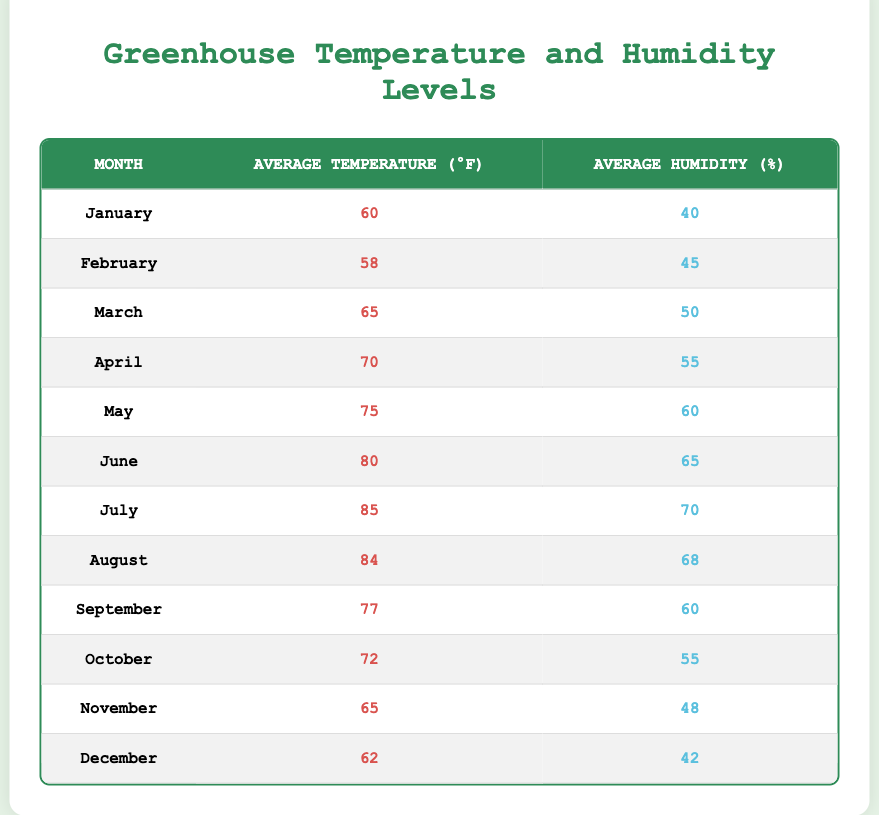What is the average temperature in July? The table indicates that the average temperature in July is 85°F.
Answer: 85°F What is the average humidity in January? According to the table, January has an average humidity of 40%.
Answer: 40% Which month has the highest average temperature? The highest average temperature is in July, which is 85°F.
Answer: July What is the average humidity for the months of June and July? To find the average, sum the average humidity values for June (65%) and July (70%), which totals 135%. Then, divide by 2 to find the average: 135% / 2 = 67.5%.
Answer: 67.5% Is the average humidity higher in December than in February? The average humidity in December is 42%, while in February it is 45%, which means February has a higher average humidity.
Answer: No What is the difference between the highest and lowest average temperatures in the table? The highest average temperature is in July (85°F) and the lowest is in February (58°F). The difference is 85°F - 58°F = 27°F.
Answer: 27°F Which month shows a decrease in average temperature from July to August? The average temperature in July is 85°F, and in August it goes down to 84°F, indicating a decrease.
Answer: Yes What is the average temperature from March to May? The average temperatures are March (65°F), April (70°F), and May (75°F). Summing these gives 65 + 70 + 75 = 210°F, and dividing by 3 gives an average of 70°F.
Answer: 70°F In which month does the average humidity peak? Highest average humidity is recorded in July with 70%.
Answer: July What is the average of the average temperatures for the first half of the year (January to June)? The average temperatures for January (60°F), February (58°F), March (65°F), April (70°F), May (75°F), and June (80°F) sum to 408°F. Dividing 408°F by 6 gives an average of 68°F.
Answer: 68°F 